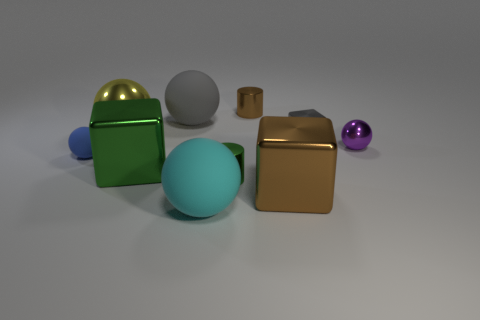Subtract 3 spheres. How many spheres are left? 2 Subtract all tiny spheres. How many spheres are left? 3 Subtract all gray spheres. How many spheres are left? 4 Subtract all cubes. How many objects are left? 7 Subtract all gray balls. Subtract all brown blocks. How many balls are left? 4 Subtract all purple metal balls. Subtract all purple shiny things. How many objects are left? 8 Add 9 small green metal things. How many small green metal things are left? 10 Add 8 tiny yellow metal blocks. How many tiny yellow metal blocks exist? 8 Subtract 0 purple cylinders. How many objects are left? 10 